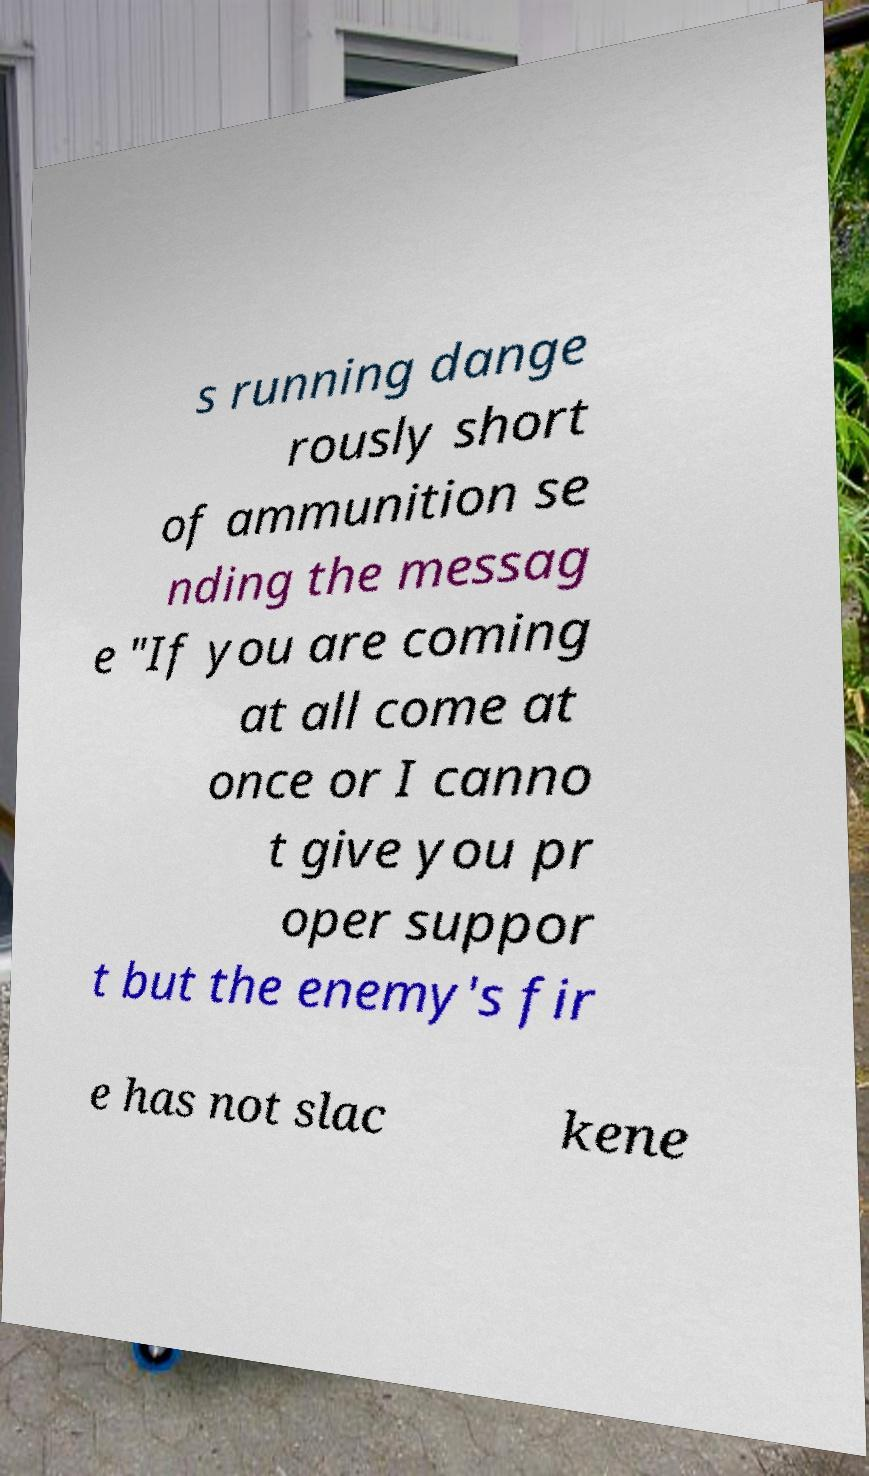Could you assist in decoding the text presented in this image and type it out clearly? s running dange rously short of ammunition se nding the messag e "If you are coming at all come at once or I canno t give you pr oper suppor t but the enemy's fir e has not slac kene 